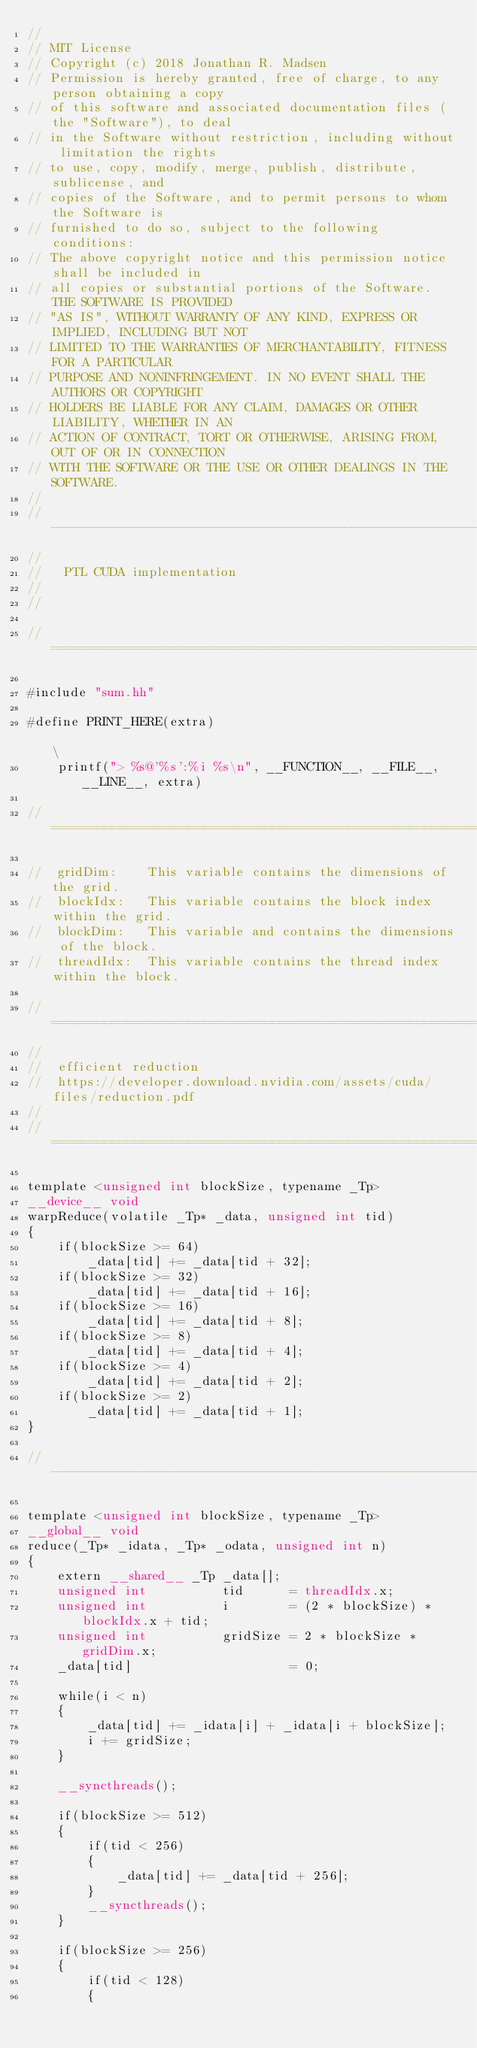<code> <loc_0><loc_0><loc_500><loc_500><_Cuda_>//
// MIT License
// Copyright (c) 2018 Jonathan R. Madsen
// Permission is hereby granted, free of charge, to any person obtaining a copy
// of this software and associated documentation files (the "Software"), to deal
// in the Software without restriction, including without limitation the rights
// to use, copy, modify, merge, publish, distribute, sublicense, and
// copies of the Software, and to permit persons to whom the Software is
// furnished to do so, subject to the following conditions:
// The above copyright notice and this permission notice shall be included in
// all copies or substantial portions of the Software. THE SOFTWARE IS PROVIDED
// "AS IS", WITHOUT WARRANTY OF ANY KIND, EXPRESS OR IMPLIED, INCLUDING BUT NOT
// LIMITED TO THE WARRANTIES OF MERCHANTABILITY, FITNESS FOR A PARTICULAR
// PURPOSE AND NONINFRINGEMENT. IN NO EVENT SHALL THE AUTHORS OR COPYRIGHT
// HOLDERS BE LIABLE FOR ANY CLAIM, DAMAGES OR OTHER LIABILITY, WHETHER IN AN
// ACTION OF CONTRACT, TORT OR OTHERWISE, ARISING FROM, OUT OF OR IN CONNECTION
// WITH THE SOFTWARE OR THE USE OR OTHER DEALINGS IN THE SOFTWARE.
//
// ---------------------------------------------------------------
//
//   PTL CUDA implementation
//
//

//============================================================================//

#include "sum.hh"

#define PRINT_HERE(extra)                                                                \
    printf("> %s@'%s':%i %s\n", __FUNCTION__, __FILE__, __LINE__, extra)

//============================================================================//

//  gridDim:    This variable contains the dimensions of the grid.
//  blockIdx:   This variable contains the block index within the grid.
//  blockDim:   This variable and contains the dimensions of the block.
//  threadIdx:  This variable contains the thread index within the block.

//============================================================================//
//
//  efficient reduction
//  https://developer.download.nvidia.com/assets/cuda/files/reduction.pdf
//
//============================================================================//

template <unsigned int blockSize, typename _Tp>
__device__ void
warpReduce(volatile _Tp* _data, unsigned int tid)
{
    if(blockSize >= 64)
        _data[tid] += _data[tid + 32];
    if(blockSize >= 32)
        _data[tid] += _data[tid + 16];
    if(blockSize >= 16)
        _data[tid] += _data[tid + 8];
    if(blockSize >= 8)
        _data[tid] += _data[tid + 4];
    if(blockSize >= 4)
        _data[tid] += _data[tid + 2];
    if(blockSize >= 2)
        _data[tid] += _data[tid + 1];
}

//----------------------------------------------------------------------------//

template <unsigned int blockSize, typename _Tp>
__global__ void
reduce(_Tp* _idata, _Tp* _odata, unsigned int n)
{
    extern __shared__ _Tp _data[];
    unsigned int          tid      = threadIdx.x;
    unsigned int          i        = (2 * blockSize) * blockIdx.x + tid;
    unsigned int          gridSize = 2 * blockSize * gridDim.x;
    _data[tid]                     = 0;

    while(i < n)
    {
        _data[tid] += _idata[i] + _idata[i + blockSize];
        i += gridSize;
    }

    __syncthreads();

    if(blockSize >= 512)
    {
        if(tid < 256)
        {
            _data[tid] += _data[tid + 256];
        }
        __syncthreads();
    }

    if(blockSize >= 256)
    {
        if(tid < 128)
        {</code> 